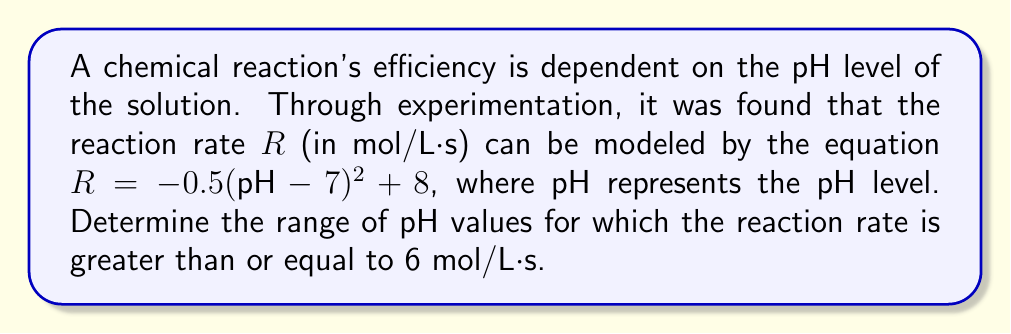What is the answer to this math problem? Let's approach this step-by-step:

1) The reaction rate $R$ is given by the equation:
   $R = -0.5(pH - 7)^2 + 8$

2) We want to find the range of pH values where $R \geq 6$. Let's set up this inequality:
   $-0.5(pH - 7)^2 + 8 \geq 6$

3) Subtract 8 from both sides:
   $-0.5(pH - 7)^2 \geq -2$

4) Divide both sides by -0.5 (and flip the inequality sign because we're dividing by a negative number):
   $(pH - 7)^2 \leq 4$

5) Take the square root of both sides. Remember, when we do this, we need to consider both positive and negative roots:
   $-2 \leq pH - 7 \leq 2$

6) Add 7 to all parts of the inequality:
   $5 \leq pH \leq 9$

Therefore, the reaction rate is greater than or equal to 6 mol/L·s when the pH is between 5 and 9, inclusive.
Answer: $5 \leq pH \leq 9$ 